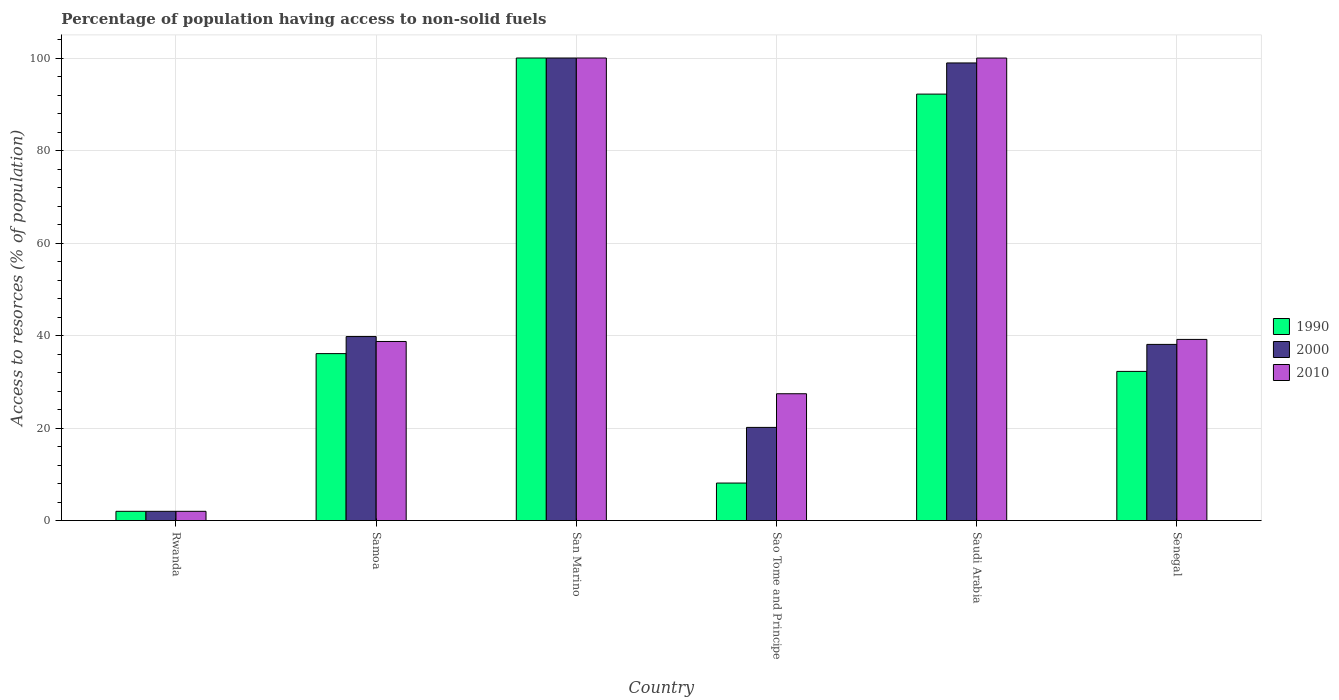How many groups of bars are there?
Offer a terse response. 6. Are the number of bars on each tick of the X-axis equal?
Offer a very short reply. Yes. How many bars are there on the 1st tick from the right?
Make the answer very short. 3. What is the label of the 5th group of bars from the left?
Give a very brief answer. Saudi Arabia. In how many cases, is the number of bars for a given country not equal to the number of legend labels?
Make the answer very short. 0. What is the percentage of population having access to non-solid fuels in 2000 in Saudi Arabia?
Your answer should be very brief. 98.93. Across all countries, what is the minimum percentage of population having access to non-solid fuels in 1990?
Offer a terse response. 2. In which country was the percentage of population having access to non-solid fuels in 1990 maximum?
Your response must be concise. San Marino. In which country was the percentage of population having access to non-solid fuels in 2010 minimum?
Make the answer very short. Rwanda. What is the total percentage of population having access to non-solid fuels in 2000 in the graph?
Provide a short and direct response. 298.95. What is the difference between the percentage of population having access to non-solid fuels in 2000 in Rwanda and that in Samoa?
Your answer should be very brief. -37.78. What is the difference between the percentage of population having access to non-solid fuels in 2000 in Saudi Arabia and the percentage of population having access to non-solid fuels in 1990 in Samoa?
Offer a very short reply. 62.84. What is the average percentage of population having access to non-solid fuels in 2000 per country?
Offer a terse response. 49.82. What is the difference between the percentage of population having access to non-solid fuels of/in 2010 and percentage of population having access to non-solid fuels of/in 1990 in Saudi Arabia?
Ensure brevity in your answer.  7.79. In how many countries, is the percentage of population having access to non-solid fuels in 2010 greater than 72 %?
Keep it short and to the point. 2. What is the ratio of the percentage of population having access to non-solid fuels in 2010 in Rwanda to that in Samoa?
Your response must be concise. 0.05. Is the percentage of population having access to non-solid fuels in 1990 in Rwanda less than that in Sao Tome and Principe?
Offer a very short reply. Yes. What is the difference between the highest and the second highest percentage of population having access to non-solid fuels in 2000?
Provide a succinct answer. -1.07. What is the difference between the highest and the lowest percentage of population having access to non-solid fuels in 2000?
Provide a short and direct response. 98. Is the sum of the percentage of population having access to non-solid fuels in 2010 in Sao Tome and Principe and Saudi Arabia greater than the maximum percentage of population having access to non-solid fuels in 2000 across all countries?
Your response must be concise. Yes. What does the 1st bar from the left in Sao Tome and Principe represents?
Give a very brief answer. 1990. What does the 1st bar from the right in Samoa represents?
Your answer should be compact. 2010. How many bars are there?
Your response must be concise. 18. Are all the bars in the graph horizontal?
Make the answer very short. No. Are the values on the major ticks of Y-axis written in scientific E-notation?
Provide a short and direct response. No. Does the graph contain any zero values?
Offer a terse response. No. Does the graph contain grids?
Give a very brief answer. Yes. Where does the legend appear in the graph?
Your answer should be very brief. Center right. How many legend labels are there?
Offer a very short reply. 3. How are the legend labels stacked?
Make the answer very short. Vertical. What is the title of the graph?
Offer a terse response. Percentage of population having access to non-solid fuels. What is the label or title of the Y-axis?
Your response must be concise. Access to resorces (% of population). What is the Access to resorces (% of population) in 1990 in Rwanda?
Make the answer very short. 2. What is the Access to resorces (% of population) of 2000 in Rwanda?
Provide a succinct answer. 2. What is the Access to resorces (% of population) in 2010 in Rwanda?
Your response must be concise. 2. What is the Access to resorces (% of population) of 1990 in Samoa?
Give a very brief answer. 36.09. What is the Access to resorces (% of population) of 2000 in Samoa?
Offer a terse response. 39.78. What is the Access to resorces (% of population) of 2010 in Samoa?
Provide a succinct answer. 38.72. What is the Access to resorces (% of population) of 1990 in San Marino?
Offer a terse response. 100. What is the Access to resorces (% of population) in 1990 in Sao Tome and Principe?
Keep it short and to the point. 8.11. What is the Access to resorces (% of population) in 2000 in Sao Tome and Principe?
Provide a short and direct response. 20.14. What is the Access to resorces (% of population) in 2010 in Sao Tome and Principe?
Keep it short and to the point. 27.42. What is the Access to resorces (% of population) of 1990 in Saudi Arabia?
Offer a terse response. 92.2. What is the Access to resorces (% of population) in 2000 in Saudi Arabia?
Provide a short and direct response. 98.93. What is the Access to resorces (% of population) of 2010 in Saudi Arabia?
Give a very brief answer. 99.99. What is the Access to resorces (% of population) in 1990 in Senegal?
Keep it short and to the point. 32.25. What is the Access to resorces (% of population) of 2000 in Senegal?
Keep it short and to the point. 38.09. What is the Access to resorces (% of population) of 2010 in Senegal?
Provide a short and direct response. 39.17. Across all countries, what is the maximum Access to resorces (% of population) of 1990?
Ensure brevity in your answer.  100. Across all countries, what is the maximum Access to resorces (% of population) of 2000?
Keep it short and to the point. 100. Across all countries, what is the minimum Access to resorces (% of population) in 1990?
Give a very brief answer. 2. Across all countries, what is the minimum Access to resorces (% of population) of 2000?
Provide a succinct answer. 2. Across all countries, what is the minimum Access to resorces (% of population) in 2010?
Your answer should be compact. 2. What is the total Access to resorces (% of population) in 1990 in the graph?
Keep it short and to the point. 270.65. What is the total Access to resorces (% of population) in 2000 in the graph?
Offer a very short reply. 298.95. What is the total Access to resorces (% of population) of 2010 in the graph?
Your response must be concise. 307.29. What is the difference between the Access to resorces (% of population) of 1990 in Rwanda and that in Samoa?
Your answer should be very brief. -34.09. What is the difference between the Access to resorces (% of population) in 2000 in Rwanda and that in Samoa?
Ensure brevity in your answer.  -37.78. What is the difference between the Access to resorces (% of population) of 2010 in Rwanda and that in Samoa?
Offer a terse response. -36.72. What is the difference between the Access to resorces (% of population) of 1990 in Rwanda and that in San Marino?
Ensure brevity in your answer.  -98. What is the difference between the Access to resorces (% of population) of 2000 in Rwanda and that in San Marino?
Offer a very short reply. -98. What is the difference between the Access to resorces (% of population) in 2010 in Rwanda and that in San Marino?
Your response must be concise. -98. What is the difference between the Access to resorces (% of population) in 1990 in Rwanda and that in Sao Tome and Principe?
Provide a short and direct response. -6.11. What is the difference between the Access to resorces (% of population) in 2000 in Rwanda and that in Sao Tome and Principe?
Give a very brief answer. -18.14. What is the difference between the Access to resorces (% of population) of 2010 in Rwanda and that in Sao Tome and Principe?
Provide a succinct answer. -25.42. What is the difference between the Access to resorces (% of population) of 1990 in Rwanda and that in Saudi Arabia?
Provide a short and direct response. -90.2. What is the difference between the Access to resorces (% of population) in 2000 in Rwanda and that in Saudi Arabia?
Ensure brevity in your answer.  -96.93. What is the difference between the Access to resorces (% of population) of 2010 in Rwanda and that in Saudi Arabia?
Provide a succinct answer. -97.99. What is the difference between the Access to resorces (% of population) in 1990 in Rwanda and that in Senegal?
Your answer should be compact. -30.25. What is the difference between the Access to resorces (% of population) of 2000 in Rwanda and that in Senegal?
Provide a short and direct response. -36.09. What is the difference between the Access to resorces (% of population) in 2010 in Rwanda and that in Senegal?
Make the answer very short. -37.17. What is the difference between the Access to resorces (% of population) of 1990 in Samoa and that in San Marino?
Your answer should be very brief. -63.91. What is the difference between the Access to resorces (% of population) of 2000 in Samoa and that in San Marino?
Ensure brevity in your answer.  -60.22. What is the difference between the Access to resorces (% of population) of 2010 in Samoa and that in San Marino?
Keep it short and to the point. -61.28. What is the difference between the Access to resorces (% of population) in 1990 in Samoa and that in Sao Tome and Principe?
Give a very brief answer. 27.98. What is the difference between the Access to resorces (% of population) of 2000 in Samoa and that in Sao Tome and Principe?
Offer a very short reply. 19.64. What is the difference between the Access to resorces (% of population) of 2010 in Samoa and that in Sao Tome and Principe?
Offer a terse response. 11.3. What is the difference between the Access to resorces (% of population) in 1990 in Samoa and that in Saudi Arabia?
Provide a short and direct response. -56.1. What is the difference between the Access to resorces (% of population) of 2000 in Samoa and that in Saudi Arabia?
Ensure brevity in your answer.  -59.15. What is the difference between the Access to resorces (% of population) of 2010 in Samoa and that in Saudi Arabia?
Provide a short and direct response. -61.27. What is the difference between the Access to resorces (% of population) of 1990 in Samoa and that in Senegal?
Ensure brevity in your answer.  3.84. What is the difference between the Access to resorces (% of population) in 2000 in Samoa and that in Senegal?
Make the answer very short. 1.7. What is the difference between the Access to resorces (% of population) of 2010 in Samoa and that in Senegal?
Provide a succinct answer. -0.45. What is the difference between the Access to resorces (% of population) of 1990 in San Marino and that in Sao Tome and Principe?
Make the answer very short. 91.89. What is the difference between the Access to resorces (% of population) of 2000 in San Marino and that in Sao Tome and Principe?
Make the answer very short. 79.86. What is the difference between the Access to resorces (% of population) of 2010 in San Marino and that in Sao Tome and Principe?
Make the answer very short. 72.58. What is the difference between the Access to resorces (% of population) in 1990 in San Marino and that in Saudi Arabia?
Keep it short and to the point. 7.8. What is the difference between the Access to resorces (% of population) in 2000 in San Marino and that in Saudi Arabia?
Keep it short and to the point. 1.07. What is the difference between the Access to resorces (% of population) of 2010 in San Marino and that in Saudi Arabia?
Your answer should be very brief. 0.01. What is the difference between the Access to resorces (% of population) in 1990 in San Marino and that in Senegal?
Your response must be concise. 67.75. What is the difference between the Access to resorces (% of population) in 2000 in San Marino and that in Senegal?
Provide a succinct answer. 61.91. What is the difference between the Access to resorces (% of population) of 2010 in San Marino and that in Senegal?
Provide a succinct answer. 60.83. What is the difference between the Access to resorces (% of population) of 1990 in Sao Tome and Principe and that in Saudi Arabia?
Make the answer very short. -84.08. What is the difference between the Access to resorces (% of population) of 2000 in Sao Tome and Principe and that in Saudi Arabia?
Your answer should be compact. -78.79. What is the difference between the Access to resorces (% of population) in 2010 in Sao Tome and Principe and that in Saudi Arabia?
Keep it short and to the point. -72.57. What is the difference between the Access to resorces (% of population) of 1990 in Sao Tome and Principe and that in Senegal?
Ensure brevity in your answer.  -24.14. What is the difference between the Access to resorces (% of population) of 2000 in Sao Tome and Principe and that in Senegal?
Provide a short and direct response. -17.94. What is the difference between the Access to resorces (% of population) of 2010 in Sao Tome and Principe and that in Senegal?
Your answer should be very brief. -11.75. What is the difference between the Access to resorces (% of population) of 1990 in Saudi Arabia and that in Senegal?
Your answer should be very brief. 59.94. What is the difference between the Access to resorces (% of population) of 2000 in Saudi Arabia and that in Senegal?
Offer a very short reply. 60.85. What is the difference between the Access to resorces (% of population) in 2010 in Saudi Arabia and that in Senegal?
Keep it short and to the point. 60.82. What is the difference between the Access to resorces (% of population) of 1990 in Rwanda and the Access to resorces (% of population) of 2000 in Samoa?
Give a very brief answer. -37.78. What is the difference between the Access to resorces (% of population) of 1990 in Rwanda and the Access to resorces (% of population) of 2010 in Samoa?
Ensure brevity in your answer.  -36.72. What is the difference between the Access to resorces (% of population) in 2000 in Rwanda and the Access to resorces (% of population) in 2010 in Samoa?
Provide a short and direct response. -36.72. What is the difference between the Access to resorces (% of population) of 1990 in Rwanda and the Access to resorces (% of population) of 2000 in San Marino?
Make the answer very short. -98. What is the difference between the Access to resorces (% of population) of 1990 in Rwanda and the Access to resorces (% of population) of 2010 in San Marino?
Offer a terse response. -98. What is the difference between the Access to resorces (% of population) in 2000 in Rwanda and the Access to resorces (% of population) in 2010 in San Marino?
Keep it short and to the point. -98. What is the difference between the Access to resorces (% of population) of 1990 in Rwanda and the Access to resorces (% of population) of 2000 in Sao Tome and Principe?
Give a very brief answer. -18.14. What is the difference between the Access to resorces (% of population) of 1990 in Rwanda and the Access to resorces (% of population) of 2010 in Sao Tome and Principe?
Keep it short and to the point. -25.42. What is the difference between the Access to resorces (% of population) of 2000 in Rwanda and the Access to resorces (% of population) of 2010 in Sao Tome and Principe?
Your answer should be very brief. -25.42. What is the difference between the Access to resorces (% of population) of 1990 in Rwanda and the Access to resorces (% of population) of 2000 in Saudi Arabia?
Provide a short and direct response. -96.93. What is the difference between the Access to resorces (% of population) of 1990 in Rwanda and the Access to resorces (% of population) of 2010 in Saudi Arabia?
Your answer should be very brief. -97.99. What is the difference between the Access to resorces (% of population) in 2000 in Rwanda and the Access to resorces (% of population) in 2010 in Saudi Arabia?
Your response must be concise. -97.99. What is the difference between the Access to resorces (% of population) in 1990 in Rwanda and the Access to resorces (% of population) in 2000 in Senegal?
Make the answer very short. -36.09. What is the difference between the Access to resorces (% of population) in 1990 in Rwanda and the Access to resorces (% of population) in 2010 in Senegal?
Give a very brief answer. -37.17. What is the difference between the Access to resorces (% of population) of 2000 in Rwanda and the Access to resorces (% of population) of 2010 in Senegal?
Provide a succinct answer. -37.17. What is the difference between the Access to resorces (% of population) of 1990 in Samoa and the Access to resorces (% of population) of 2000 in San Marino?
Provide a short and direct response. -63.91. What is the difference between the Access to resorces (% of population) of 1990 in Samoa and the Access to resorces (% of population) of 2010 in San Marino?
Make the answer very short. -63.91. What is the difference between the Access to resorces (% of population) of 2000 in Samoa and the Access to resorces (% of population) of 2010 in San Marino?
Keep it short and to the point. -60.22. What is the difference between the Access to resorces (% of population) of 1990 in Samoa and the Access to resorces (% of population) of 2000 in Sao Tome and Principe?
Provide a short and direct response. 15.95. What is the difference between the Access to resorces (% of population) in 1990 in Samoa and the Access to resorces (% of population) in 2010 in Sao Tome and Principe?
Your answer should be very brief. 8.68. What is the difference between the Access to resorces (% of population) in 2000 in Samoa and the Access to resorces (% of population) in 2010 in Sao Tome and Principe?
Make the answer very short. 12.36. What is the difference between the Access to resorces (% of population) in 1990 in Samoa and the Access to resorces (% of population) in 2000 in Saudi Arabia?
Provide a short and direct response. -62.84. What is the difference between the Access to resorces (% of population) in 1990 in Samoa and the Access to resorces (% of population) in 2010 in Saudi Arabia?
Ensure brevity in your answer.  -63.9. What is the difference between the Access to resorces (% of population) of 2000 in Samoa and the Access to resorces (% of population) of 2010 in Saudi Arabia?
Your answer should be compact. -60.21. What is the difference between the Access to resorces (% of population) of 1990 in Samoa and the Access to resorces (% of population) of 2000 in Senegal?
Your answer should be compact. -1.99. What is the difference between the Access to resorces (% of population) of 1990 in Samoa and the Access to resorces (% of population) of 2010 in Senegal?
Keep it short and to the point. -3.07. What is the difference between the Access to resorces (% of population) in 2000 in Samoa and the Access to resorces (% of population) in 2010 in Senegal?
Keep it short and to the point. 0.62. What is the difference between the Access to resorces (% of population) in 1990 in San Marino and the Access to resorces (% of population) in 2000 in Sao Tome and Principe?
Your response must be concise. 79.86. What is the difference between the Access to resorces (% of population) in 1990 in San Marino and the Access to resorces (% of population) in 2010 in Sao Tome and Principe?
Make the answer very short. 72.58. What is the difference between the Access to resorces (% of population) of 2000 in San Marino and the Access to resorces (% of population) of 2010 in Sao Tome and Principe?
Your answer should be compact. 72.58. What is the difference between the Access to resorces (% of population) in 1990 in San Marino and the Access to resorces (% of population) in 2000 in Saudi Arabia?
Provide a short and direct response. 1.07. What is the difference between the Access to resorces (% of population) of 1990 in San Marino and the Access to resorces (% of population) of 2010 in Saudi Arabia?
Keep it short and to the point. 0.01. What is the difference between the Access to resorces (% of population) of 2000 in San Marino and the Access to resorces (% of population) of 2010 in Saudi Arabia?
Your response must be concise. 0.01. What is the difference between the Access to resorces (% of population) in 1990 in San Marino and the Access to resorces (% of population) in 2000 in Senegal?
Make the answer very short. 61.91. What is the difference between the Access to resorces (% of population) in 1990 in San Marino and the Access to resorces (% of population) in 2010 in Senegal?
Offer a terse response. 60.83. What is the difference between the Access to resorces (% of population) in 2000 in San Marino and the Access to resorces (% of population) in 2010 in Senegal?
Your answer should be very brief. 60.83. What is the difference between the Access to resorces (% of population) of 1990 in Sao Tome and Principe and the Access to resorces (% of population) of 2000 in Saudi Arabia?
Your response must be concise. -90.82. What is the difference between the Access to resorces (% of population) in 1990 in Sao Tome and Principe and the Access to resorces (% of population) in 2010 in Saudi Arabia?
Offer a very short reply. -91.88. What is the difference between the Access to resorces (% of population) of 2000 in Sao Tome and Principe and the Access to resorces (% of population) of 2010 in Saudi Arabia?
Your response must be concise. -79.85. What is the difference between the Access to resorces (% of population) of 1990 in Sao Tome and Principe and the Access to resorces (% of population) of 2000 in Senegal?
Ensure brevity in your answer.  -29.97. What is the difference between the Access to resorces (% of population) in 1990 in Sao Tome and Principe and the Access to resorces (% of population) in 2010 in Senegal?
Offer a terse response. -31.05. What is the difference between the Access to resorces (% of population) of 2000 in Sao Tome and Principe and the Access to resorces (% of population) of 2010 in Senegal?
Make the answer very short. -19.02. What is the difference between the Access to resorces (% of population) in 1990 in Saudi Arabia and the Access to resorces (% of population) in 2000 in Senegal?
Your answer should be compact. 54.11. What is the difference between the Access to resorces (% of population) of 1990 in Saudi Arabia and the Access to resorces (% of population) of 2010 in Senegal?
Offer a very short reply. 53.03. What is the difference between the Access to resorces (% of population) of 2000 in Saudi Arabia and the Access to resorces (% of population) of 2010 in Senegal?
Ensure brevity in your answer.  59.77. What is the average Access to resorces (% of population) of 1990 per country?
Your answer should be very brief. 45.11. What is the average Access to resorces (% of population) of 2000 per country?
Provide a succinct answer. 49.82. What is the average Access to resorces (% of population) of 2010 per country?
Provide a short and direct response. 51.22. What is the difference between the Access to resorces (% of population) in 1990 and Access to resorces (% of population) in 2000 in Rwanda?
Your answer should be very brief. 0. What is the difference between the Access to resorces (% of population) in 1990 and Access to resorces (% of population) in 2000 in Samoa?
Your response must be concise. -3.69. What is the difference between the Access to resorces (% of population) in 1990 and Access to resorces (% of population) in 2010 in Samoa?
Ensure brevity in your answer.  -2.62. What is the difference between the Access to resorces (% of population) in 2000 and Access to resorces (% of population) in 2010 in Samoa?
Your response must be concise. 1.07. What is the difference between the Access to resorces (% of population) of 1990 and Access to resorces (% of population) of 2010 in San Marino?
Offer a very short reply. 0. What is the difference between the Access to resorces (% of population) of 1990 and Access to resorces (% of population) of 2000 in Sao Tome and Principe?
Your answer should be compact. -12.03. What is the difference between the Access to resorces (% of population) of 1990 and Access to resorces (% of population) of 2010 in Sao Tome and Principe?
Give a very brief answer. -19.31. What is the difference between the Access to resorces (% of population) in 2000 and Access to resorces (% of population) in 2010 in Sao Tome and Principe?
Provide a short and direct response. -7.27. What is the difference between the Access to resorces (% of population) in 1990 and Access to resorces (% of population) in 2000 in Saudi Arabia?
Your answer should be very brief. -6.74. What is the difference between the Access to resorces (% of population) of 1990 and Access to resorces (% of population) of 2010 in Saudi Arabia?
Provide a succinct answer. -7.79. What is the difference between the Access to resorces (% of population) in 2000 and Access to resorces (% of population) in 2010 in Saudi Arabia?
Give a very brief answer. -1.06. What is the difference between the Access to resorces (% of population) of 1990 and Access to resorces (% of population) of 2000 in Senegal?
Give a very brief answer. -5.83. What is the difference between the Access to resorces (% of population) in 1990 and Access to resorces (% of population) in 2010 in Senegal?
Your answer should be very brief. -6.91. What is the difference between the Access to resorces (% of population) in 2000 and Access to resorces (% of population) in 2010 in Senegal?
Offer a very short reply. -1.08. What is the ratio of the Access to resorces (% of population) of 1990 in Rwanda to that in Samoa?
Offer a very short reply. 0.06. What is the ratio of the Access to resorces (% of population) in 2000 in Rwanda to that in Samoa?
Make the answer very short. 0.05. What is the ratio of the Access to resorces (% of population) of 2010 in Rwanda to that in Samoa?
Your response must be concise. 0.05. What is the ratio of the Access to resorces (% of population) in 1990 in Rwanda to that in San Marino?
Make the answer very short. 0.02. What is the ratio of the Access to resorces (% of population) in 1990 in Rwanda to that in Sao Tome and Principe?
Your answer should be compact. 0.25. What is the ratio of the Access to resorces (% of population) of 2000 in Rwanda to that in Sao Tome and Principe?
Keep it short and to the point. 0.1. What is the ratio of the Access to resorces (% of population) in 2010 in Rwanda to that in Sao Tome and Principe?
Provide a short and direct response. 0.07. What is the ratio of the Access to resorces (% of population) in 1990 in Rwanda to that in Saudi Arabia?
Your response must be concise. 0.02. What is the ratio of the Access to resorces (% of population) in 2000 in Rwanda to that in Saudi Arabia?
Ensure brevity in your answer.  0.02. What is the ratio of the Access to resorces (% of population) of 2010 in Rwanda to that in Saudi Arabia?
Provide a succinct answer. 0.02. What is the ratio of the Access to resorces (% of population) of 1990 in Rwanda to that in Senegal?
Your response must be concise. 0.06. What is the ratio of the Access to resorces (% of population) in 2000 in Rwanda to that in Senegal?
Provide a succinct answer. 0.05. What is the ratio of the Access to resorces (% of population) of 2010 in Rwanda to that in Senegal?
Your answer should be compact. 0.05. What is the ratio of the Access to resorces (% of population) in 1990 in Samoa to that in San Marino?
Offer a terse response. 0.36. What is the ratio of the Access to resorces (% of population) of 2000 in Samoa to that in San Marino?
Ensure brevity in your answer.  0.4. What is the ratio of the Access to resorces (% of population) in 2010 in Samoa to that in San Marino?
Give a very brief answer. 0.39. What is the ratio of the Access to resorces (% of population) of 1990 in Samoa to that in Sao Tome and Principe?
Your response must be concise. 4.45. What is the ratio of the Access to resorces (% of population) of 2000 in Samoa to that in Sao Tome and Principe?
Offer a very short reply. 1.97. What is the ratio of the Access to resorces (% of population) of 2010 in Samoa to that in Sao Tome and Principe?
Give a very brief answer. 1.41. What is the ratio of the Access to resorces (% of population) in 1990 in Samoa to that in Saudi Arabia?
Ensure brevity in your answer.  0.39. What is the ratio of the Access to resorces (% of population) in 2000 in Samoa to that in Saudi Arabia?
Ensure brevity in your answer.  0.4. What is the ratio of the Access to resorces (% of population) of 2010 in Samoa to that in Saudi Arabia?
Make the answer very short. 0.39. What is the ratio of the Access to resorces (% of population) of 1990 in Samoa to that in Senegal?
Ensure brevity in your answer.  1.12. What is the ratio of the Access to resorces (% of population) of 2000 in Samoa to that in Senegal?
Provide a succinct answer. 1.04. What is the ratio of the Access to resorces (% of population) of 1990 in San Marino to that in Sao Tome and Principe?
Your answer should be compact. 12.33. What is the ratio of the Access to resorces (% of population) of 2000 in San Marino to that in Sao Tome and Principe?
Ensure brevity in your answer.  4.96. What is the ratio of the Access to resorces (% of population) in 2010 in San Marino to that in Sao Tome and Principe?
Your answer should be compact. 3.65. What is the ratio of the Access to resorces (% of population) of 1990 in San Marino to that in Saudi Arabia?
Provide a succinct answer. 1.08. What is the ratio of the Access to resorces (% of population) of 2000 in San Marino to that in Saudi Arabia?
Your answer should be compact. 1.01. What is the ratio of the Access to resorces (% of population) in 2010 in San Marino to that in Saudi Arabia?
Ensure brevity in your answer.  1. What is the ratio of the Access to resorces (% of population) of 1990 in San Marino to that in Senegal?
Your response must be concise. 3.1. What is the ratio of the Access to resorces (% of population) of 2000 in San Marino to that in Senegal?
Offer a terse response. 2.63. What is the ratio of the Access to resorces (% of population) of 2010 in San Marino to that in Senegal?
Give a very brief answer. 2.55. What is the ratio of the Access to resorces (% of population) in 1990 in Sao Tome and Principe to that in Saudi Arabia?
Your answer should be compact. 0.09. What is the ratio of the Access to resorces (% of population) of 2000 in Sao Tome and Principe to that in Saudi Arabia?
Provide a short and direct response. 0.2. What is the ratio of the Access to resorces (% of population) of 2010 in Sao Tome and Principe to that in Saudi Arabia?
Your answer should be compact. 0.27. What is the ratio of the Access to resorces (% of population) in 1990 in Sao Tome and Principe to that in Senegal?
Offer a very short reply. 0.25. What is the ratio of the Access to resorces (% of population) of 2000 in Sao Tome and Principe to that in Senegal?
Keep it short and to the point. 0.53. What is the ratio of the Access to resorces (% of population) of 2010 in Sao Tome and Principe to that in Senegal?
Ensure brevity in your answer.  0.7. What is the ratio of the Access to resorces (% of population) in 1990 in Saudi Arabia to that in Senegal?
Provide a succinct answer. 2.86. What is the ratio of the Access to resorces (% of population) in 2000 in Saudi Arabia to that in Senegal?
Provide a short and direct response. 2.6. What is the ratio of the Access to resorces (% of population) in 2010 in Saudi Arabia to that in Senegal?
Provide a succinct answer. 2.55. What is the difference between the highest and the second highest Access to resorces (% of population) of 1990?
Your answer should be very brief. 7.8. What is the difference between the highest and the second highest Access to resorces (% of population) of 2000?
Make the answer very short. 1.07. What is the difference between the highest and the lowest Access to resorces (% of population) in 1990?
Make the answer very short. 98. 